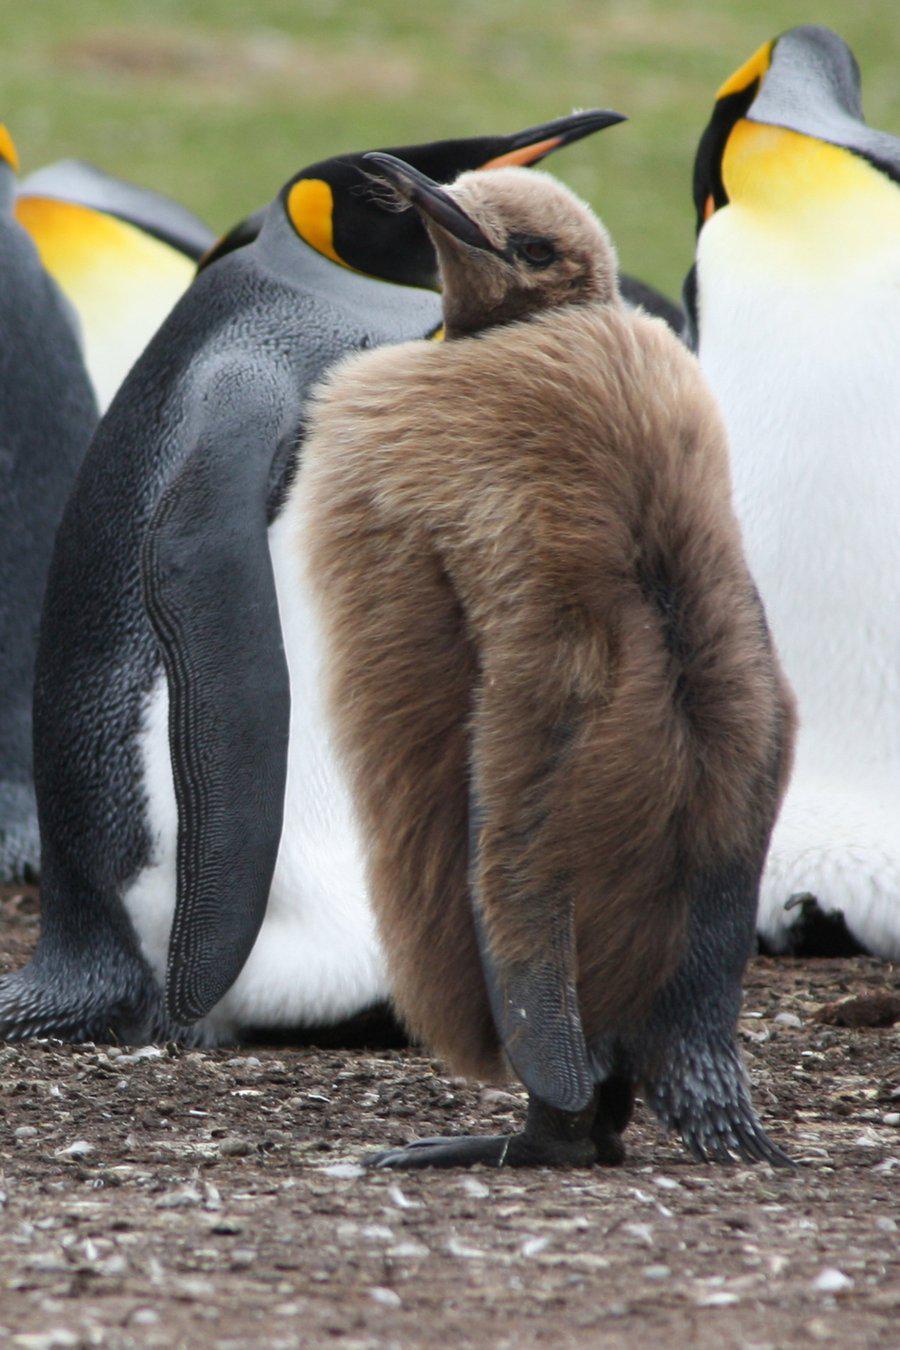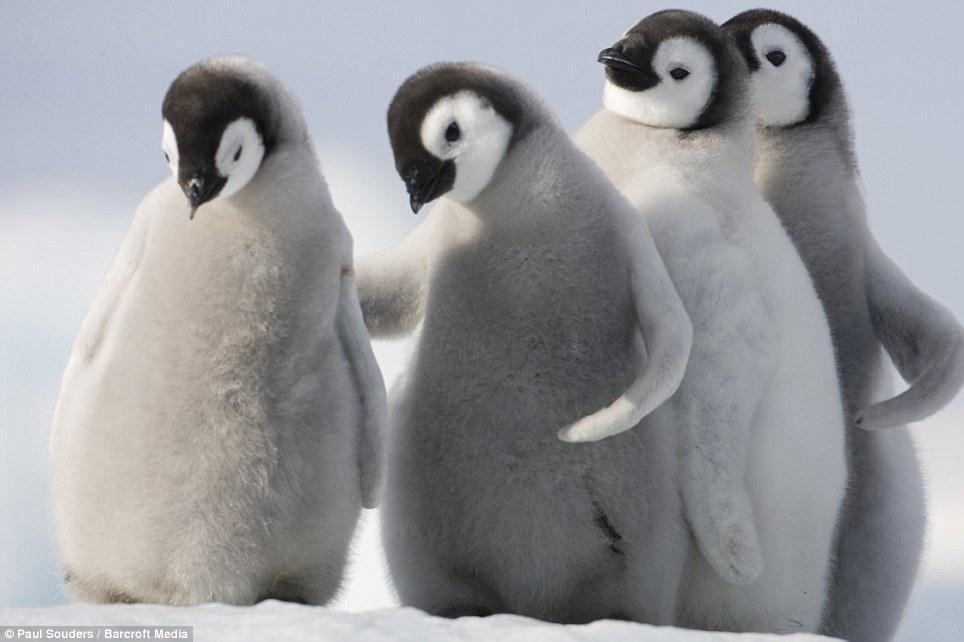The first image is the image on the left, the second image is the image on the right. Given the left and right images, does the statement "One image includes a penguin with brown fuzzy feathers, and the other includes a gray fuzzy baby penguin." hold true? Answer yes or no. Yes. The first image is the image on the left, the second image is the image on the right. Analyze the images presented: Is the assertion "In one of the photos, one of the penguins is brown, and in the other, none of the penguins are brown." valid? Answer yes or no. Yes. 